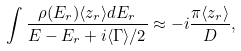Convert formula to latex. <formula><loc_0><loc_0><loc_500><loc_500>\int \frac { \rho ( E _ { r } ) \langle z _ { r } \rangle d E _ { r } } { E - E _ { r } + i \langle \Gamma \rangle / 2 } \approx - i \frac { \pi \langle z _ { r } \rangle } { D } ,</formula> 